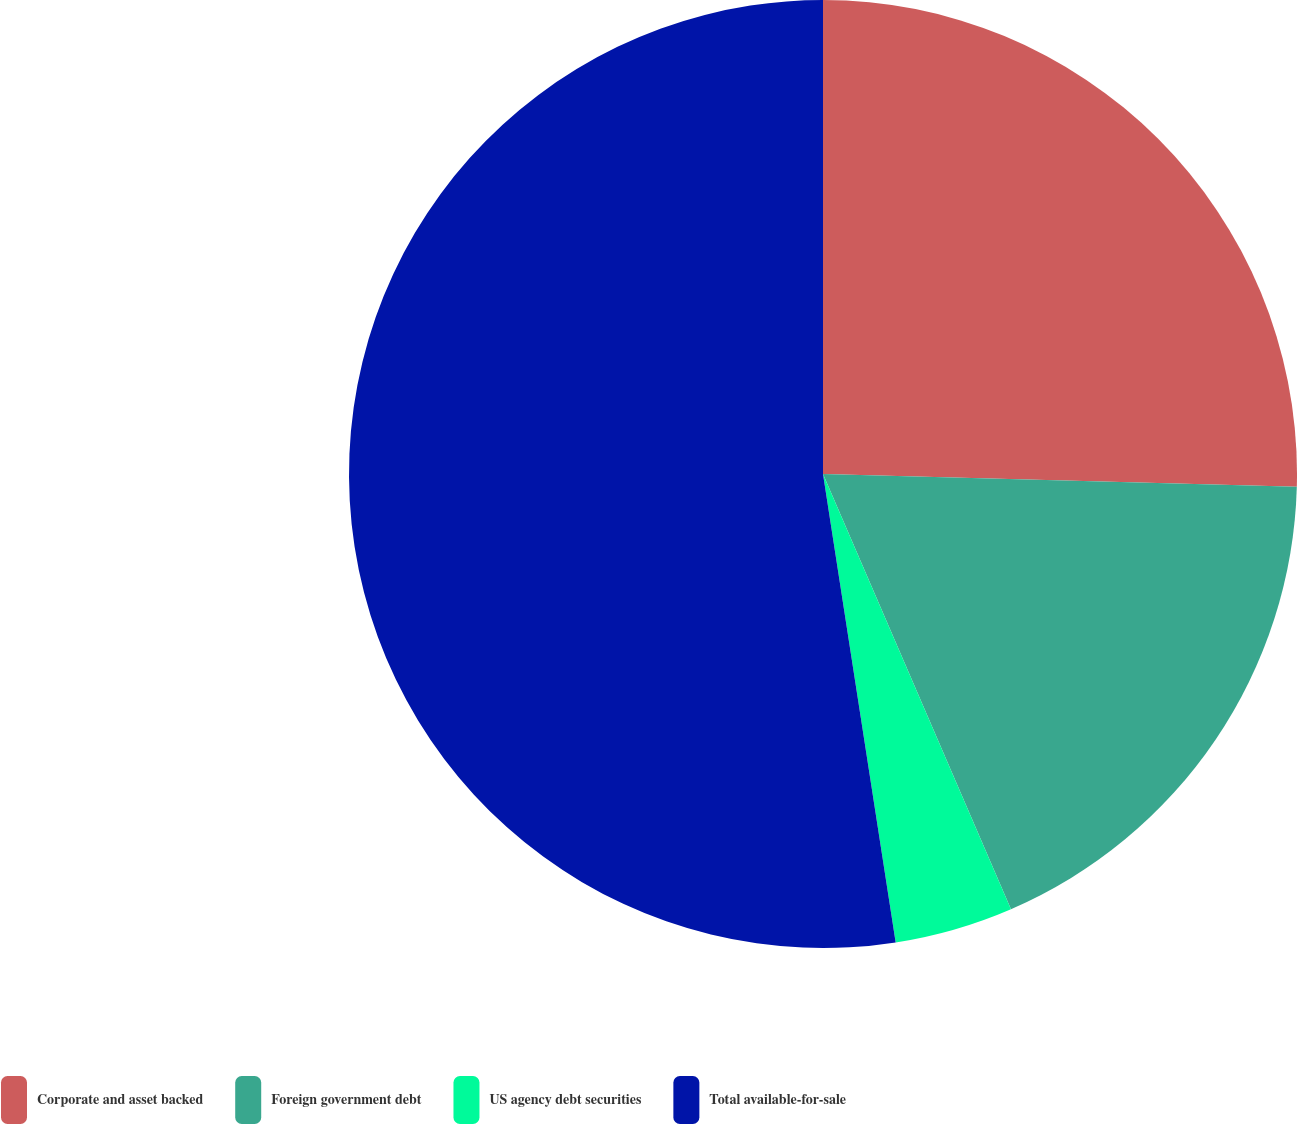Convert chart to OTSL. <chart><loc_0><loc_0><loc_500><loc_500><pie_chart><fcel>Corporate and asset backed<fcel>Foreign government debt<fcel>US agency debt securities<fcel>Total available-for-sale<nl><fcel>25.43%<fcel>18.08%<fcel>4.04%<fcel>52.45%<nl></chart> 